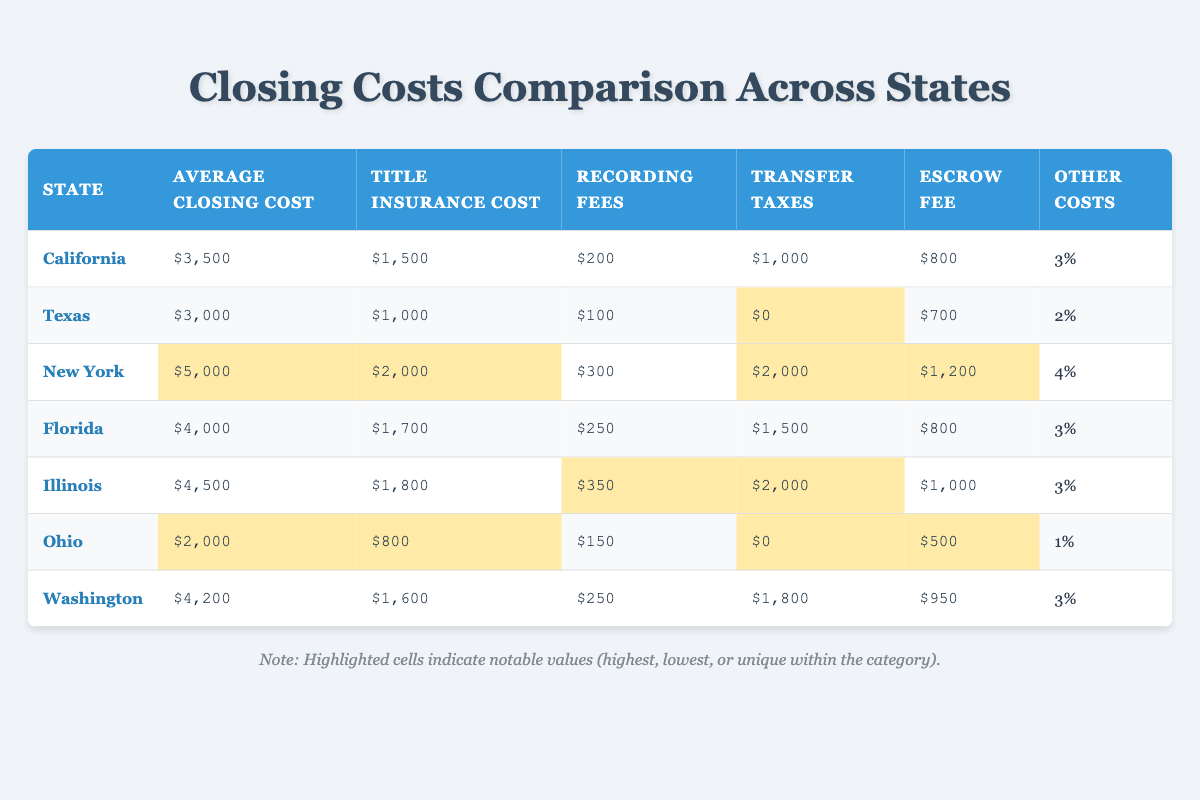What is the average closing cost in California? The table shows that the average closing cost in California is listed as $3,500.
Answer: $3,500 Which state has the highest title insurance cost? By examining the title insurance cost column, New York shows the highest cost at $2,000.
Answer: New York What is the total cost of closing in Texas (including all fees)? The sum of all fees in Texas is $3,000 (average closing cost), $1,000 (title insurance cost), $100 (recording fees), $0 (transfer taxes), $700 (escrow fee), and 2% (other costs). So, it totals to $3,000.
Answer: $3,000 How much more does New York's average closing cost compare to Ohio's? New York's average closing cost is $5,000, and Ohio's is $2,000. The difference is $5,000 - $2,000 = $3,000.
Answer: $3,000 Are transfer taxes required in Texas? The table shows that the transfer taxes for Texas are listed as $0, indicating that no transfer taxes are required.
Answer: No What are the average closing costs for states that have an average closing cost above $4,000? The states with an average closing cost above $4,000 are New York ($5,000), Illinois ($4,500), and Florida ($4,000). Hence, the average of these three amounts is ($5,000 + $4,500 + $4,000) / 3 = $4,500.
Answer: $4,500 Which state has the lowest closing costs and what is the amount? Reviewing the table reveals that Ohio has the lowest average closing cost at $2,000.
Answer: Ohio, $2,000 What percentage of the total closing cost in Florida is attributed to title insurance? The title insurance cost in Florida is $1,700 and the average closing cost is $4,000. The percentage is ($1,700 / $4,000) * 100 = 42.5%.
Answer: 42.5% Is the recording fee in Illinois the highest among the states listed? The recording fee in Illinois is $350, while the highest fee in the table is for New York at $300, so Illinois does not have the highest recording fee.
Answer: No What is the combined amount of escrow fees in states with average closing costs over $4,000? The states with average closing costs over $4,000 are New York ($1,200), Florida ($800), and Illinois ($1,000). Therefore, the combined amount is $1,200 + $800 + $1,000 = $3,000.
Answer: $3,000 